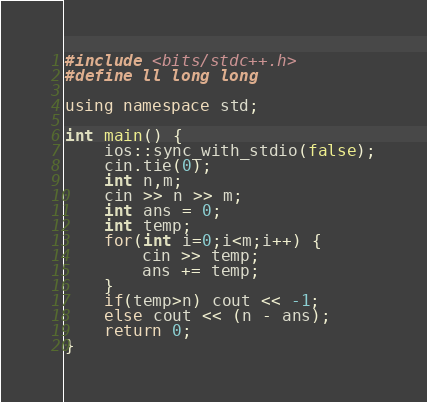<code> <loc_0><loc_0><loc_500><loc_500><_C++_>#include <bits/stdc++.h>
#define ll long long

using namespace std;

int main() {
	ios::sync_with_stdio(false);
	cin.tie(0);
	int n,m;
	cin >> n >> m;
	int ans = 0;
	int temp;
	for(int i=0;i<m;i++) {
		cin >> temp;
		ans += temp;
	}
	if(temp>n) cout << -1;
	else cout << (n - ans);
	return 0;
}

</code> 